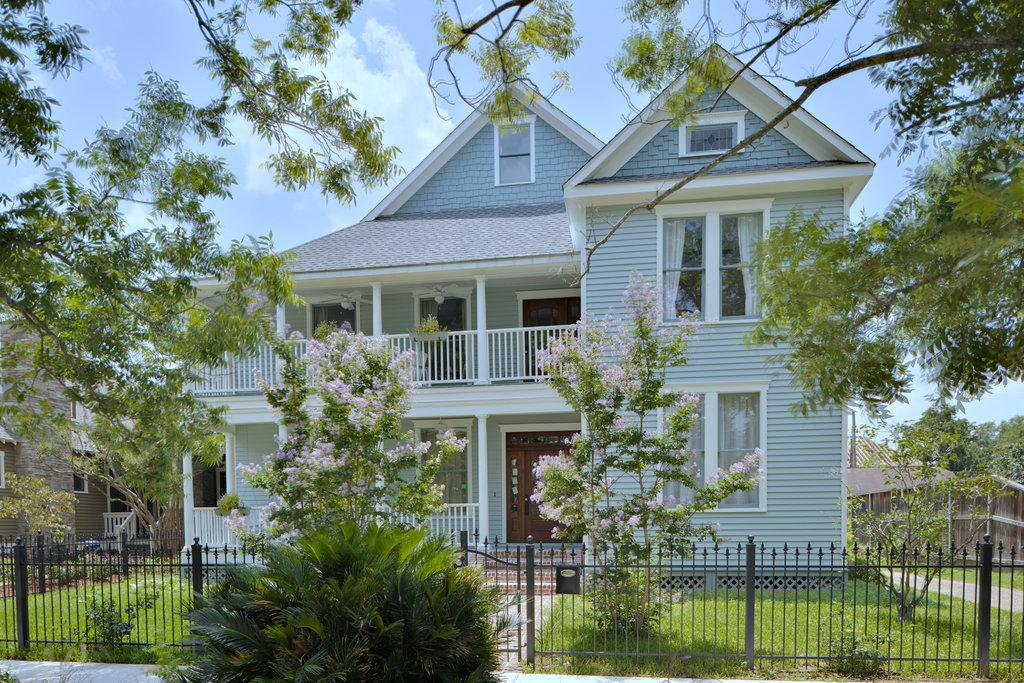What type of vegetation is present in the image? There is grass and plants in the image. What type of structures can be seen in the image? There are iron grilles and houses in the image. What type of natural elements are present in the image? There are trees in the image. What is visible in the background of the image? The sky is visible in the background of the image. Can you tell me how many geese are flying in the image? There are no geese present in the image; it features grass, plants, iron grilles, houses, trees, and the sky. What type of silver object is visible in the image? There is no silver object present in the image. 